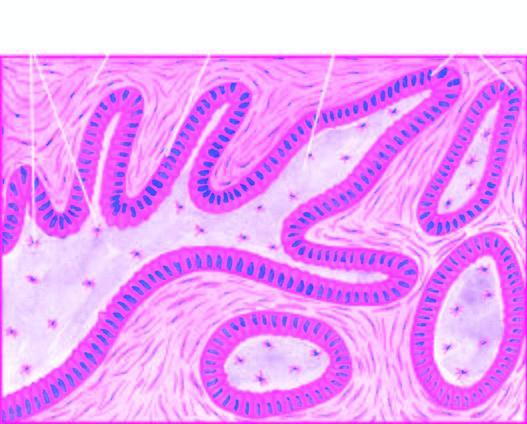do common locations and the regions of involvement show central cystic change?
Answer the question using a single word or phrase. No 